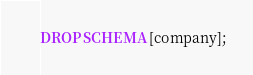<code> <loc_0><loc_0><loc_500><loc_500><_SQL_>DROP SCHEMA [company];</code> 